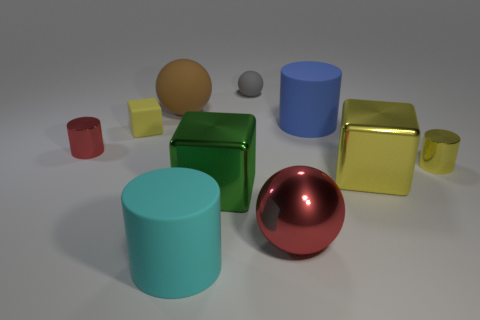What size is the cylinder that is the same color as the rubber cube?
Give a very brief answer. Small. How many things are either small red metal objects or metallic blocks?
Your answer should be very brief. 3. What color is the metallic sphere that is the same size as the green shiny block?
Keep it short and to the point. Red. There is a brown rubber object; does it have the same shape as the small yellow thing that is to the right of the blue rubber object?
Keep it short and to the point. No. What number of things are either cylinders that are in front of the big red metal ball or big cylinders that are to the right of the cyan cylinder?
Offer a very short reply. 2. What shape is the big shiny object that is the same color as the matte block?
Ensure brevity in your answer.  Cube. What is the shape of the large matte object on the right side of the big red ball?
Make the answer very short. Cylinder. There is a small rubber object on the right side of the large brown matte sphere; does it have the same shape as the big red metallic object?
Provide a succinct answer. Yes. How many things are either small rubber objects that are on the left side of the big brown rubber object or large purple blocks?
Provide a succinct answer. 1. The other big matte thing that is the same shape as the big cyan rubber thing is what color?
Keep it short and to the point. Blue. 